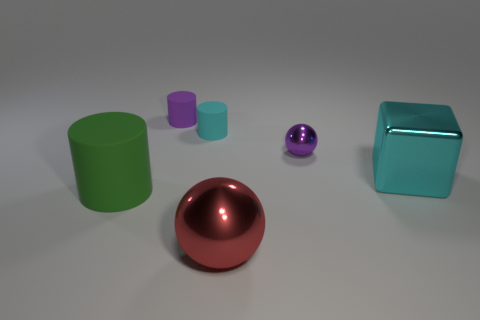There is a matte cylinder that is the same color as the small ball; what size is it?
Keep it short and to the point. Small. What is the ball behind the matte cylinder that is in front of the tiny sphere made of?
Offer a very short reply. Metal. Are there any matte things that have the same color as the big metal cube?
Offer a very short reply. Yes. What color is the sphere that is the same size as the green rubber thing?
Keep it short and to the point. Red. The sphere in front of the large metal thing to the right of the metallic ball that is in front of the big cyan cube is made of what material?
Your answer should be very brief. Metal. There is a large block; does it have the same color as the small rubber thing in front of the small purple matte cylinder?
Your answer should be compact. Yes. What number of things are matte cylinders behind the large cylinder or big objects that are right of the large rubber object?
Make the answer very short. 4. The tiny purple object to the right of the metal ball in front of the purple shiny ball is what shape?
Your answer should be very brief. Sphere. Is there a small thing that has the same material as the cyan cylinder?
Give a very brief answer. Yes. The other tiny metal object that is the same shape as the red metallic object is what color?
Make the answer very short. Purple. 